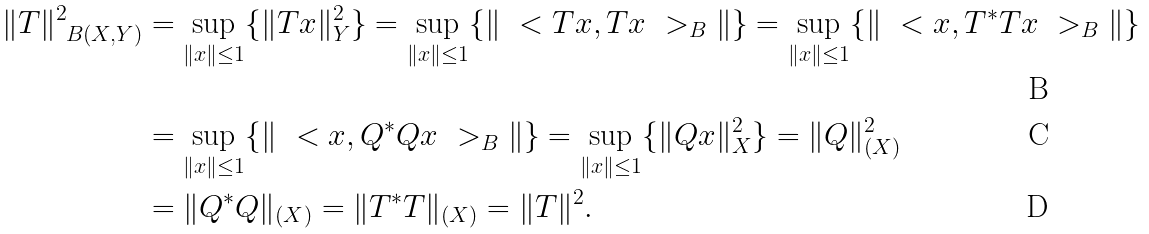Convert formula to latex. <formula><loc_0><loc_0><loc_500><loc_500>\| T \| ^ { 2 } _ { \ B ( X , Y ) } & = \sup _ { \| x \| \leq 1 } \{ \| T x \| ^ { 2 } _ { Y } \} = \sup _ { \| x \| \leq 1 } \{ \| \ < T x , T x \ > _ { B } \| \} = \sup _ { \| x \| \leq 1 } \{ \| \ < x , T ^ { * } T x \ > _ { B } \| \} \\ & = \sup _ { \| x \| \leq 1 } \{ \| \ < x , Q ^ { * } Q x \ > _ { B } \| \} = \sup _ { \| x \| \leq 1 } \{ \| Q x \| ^ { 2 } _ { X } \} = \| Q \| ^ { 2 } _ { \L ( X ) } \\ & = \| Q ^ { * } Q \| _ { \L ( X ) } = \| T ^ { * } T \| _ { \L ( X ) } = \| T \| ^ { 2 } .</formula> 